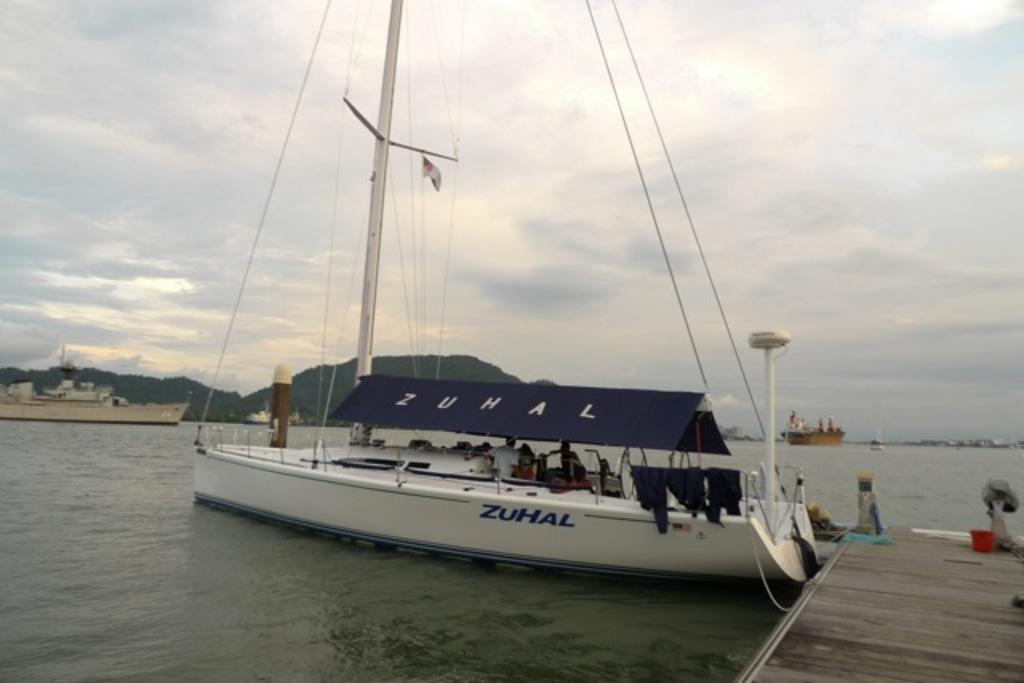What are the people in the image doing? There is a group of people in a boat in the image. Where is the boat located? The boat is on the water. What can be seen in the background of the image? There are ships, a wooden bridge, hills, trees, and the sky visible in the background. What type of cakes are being served on the wooden bridge in the image? There are no cakes present in the image, and the wooden bridge is in the background, not serving any food. 